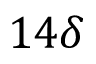Convert formula to latex. <formula><loc_0><loc_0><loc_500><loc_500>1 4 \delta</formula> 